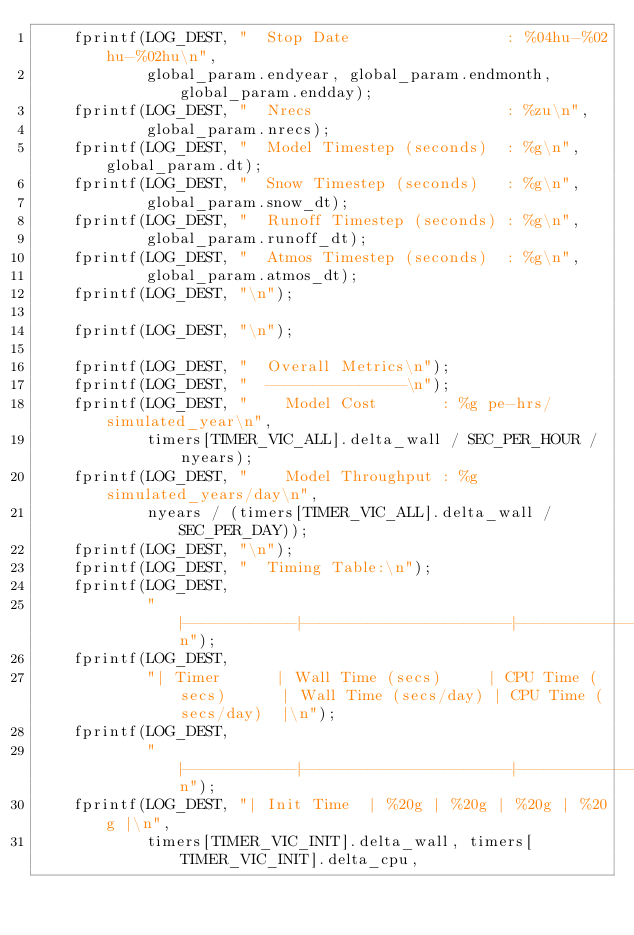<code> <loc_0><loc_0><loc_500><loc_500><_C_>    fprintf(LOG_DEST, "  Stop Date                 : %04hu-%02hu-%02hu\n",
            global_param.endyear, global_param.endmonth, global_param.endday);
    fprintf(LOG_DEST, "  Nrecs                     : %zu\n",
            global_param.nrecs);
    fprintf(LOG_DEST, "  Model Timestep (seconds)  : %g\n", global_param.dt);
    fprintf(LOG_DEST, "  Snow Timestep (seconds)   : %g\n",
            global_param.snow_dt);
    fprintf(LOG_DEST, "  Runoff Timestep (seconds) : %g\n",
            global_param.runoff_dt);
    fprintf(LOG_DEST, "  Atmos Timestep (seconds)  : %g\n",
            global_param.atmos_dt);
    fprintf(LOG_DEST, "\n");

    fprintf(LOG_DEST, "\n");

    fprintf(LOG_DEST, "  Overall Metrics\n");
    fprintf(LOG_DEST, "  ---------------\n");
    fprintf(LOG_DEST, "    Model Cost       : %g pe-hrs/simulated_year\n",
            timers[TIMER_VIC_ALL].delta_wall / SEC_PER_HOUR / nyears);
    fprintf(LOG_DEST, "    Model Throughput : %g simulated_years/day\n",
            nyears / (timers[TIMER_VIC_ALL].delta_wall / SEC_PER_DAY));
    fprintf(LOG_DEST, "\n");
    fprintf(LOG_DEST, "  Timing Table:\n");
    fprintf(LOG_DEST,
            "|------------|----------------------|----------------------|----------------------|----------------------|\n");
    fprintf(LOG_DEST,
            "| Timer      | Wall Time (secs)     | CPU Time (secs)      | Wall Time (secs/day) | CPU Time (secs/day)  |\n");
    fprintf(LOG_DEST,
            "|------------|----------------------|----------------------|----------------------|----------------------|\n");
    fprintf(LOG_DEST, "| Init Time  | %20g | %20g | %20g | %20g |\n",
            timers[TIMER_VIC_INIT].delta_wall, timers[TIMER_VIC_INIT].delta_cpu,</code> 